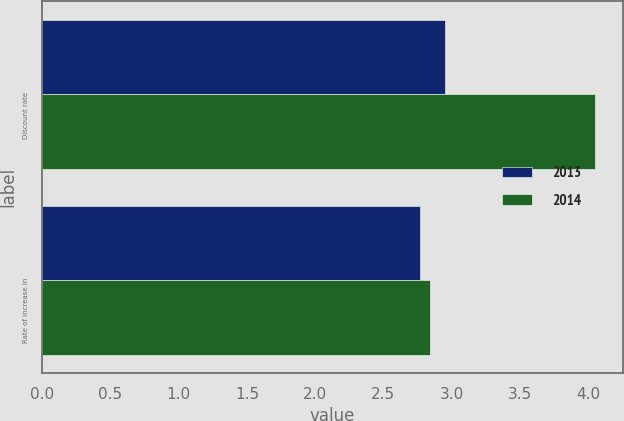Convert chart. <chart><loc_0><loc_0><loc_500><loc_500><stacked_bar_chart><ecel><fcel>Discount rate<fcel>Rate of increase in<nl><fcel>2013<fcel>2.95<fcel>2.77<nl><fcel>2014<fcel>4.05<fcel>2.84<nl></chart> 